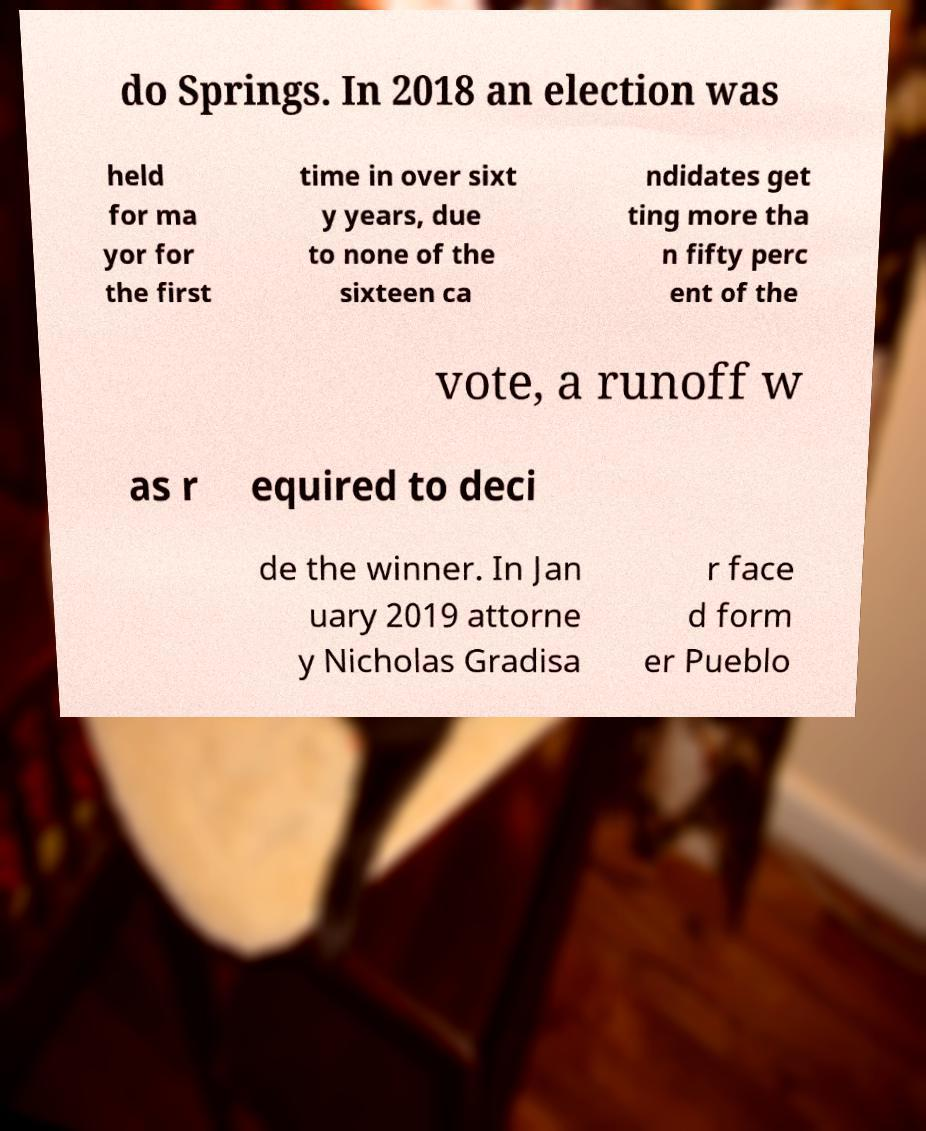Could you assist in decoding the text presented in this image and type it out clearly? do Springs. In 2018 an election was held for ma yor for the first time in over sixt y years, due to none of the sixteen ca ndidates get ting more tha n fifty perc ent of the vote, a runoff w as r equired to deci de the winner. In Jan uary 2019 attorne y Nicholas Gradisa r face d form er Pueblo 